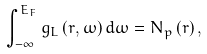<formula> <loc_0><loc_0><loc_500><loc_500>\int _ { - \infty } ^ { E _ { F } } g _ { L } \left ( r , \omega \right ) d \omega = N _ { p } \left ( r \right ) ,</formula> 